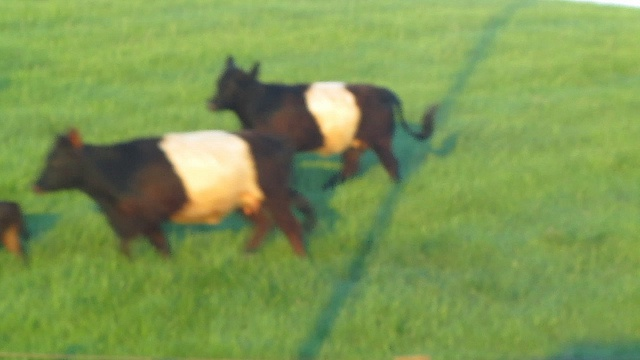Describe the objects in this image and their specific colors. I can see cow in lightgreen, gray, black, and beige tones, cow in lightgreen, gray, black, and maroon tones, and cow in lightgreen, olive, and black tones in this image. 